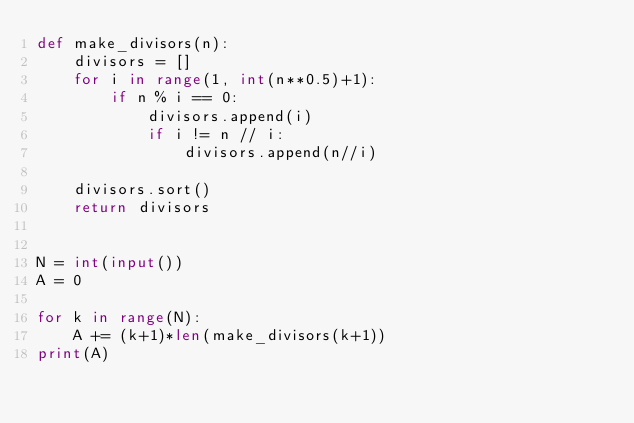<code> <loc_0><loc_0><loc_500><loc_500><_Python_>def make_divisors(n):
    divisors = []
    for i in range(1, int(n**0.5)+1):
        if n % i == 0:
            divisors.append(i)
            if i != n // i:
                divisors.append(n//i)

    divisors.sort()
    return divisors


N = int(input())
A = 0

for k in range(N):
    A += (k+1)*len(make_divisors(k+1))
print(A)</code> 